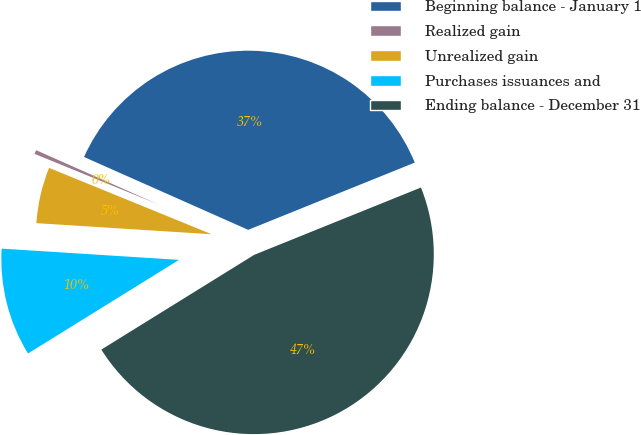<chart> <loc_0><loc_0><loc_500><loc_500><pie_chart><fcel>Beginning balance - January 1<fcel>Realized gain<fcel>Unrealized gain<fcel>Purchases issuances and<fcel>Ending balance - December 31<nl><fcel>37.25%<fcel>0.48%<fcel>5.16%<fcel>9.84%<fcel>47.28%<nl></chart> 